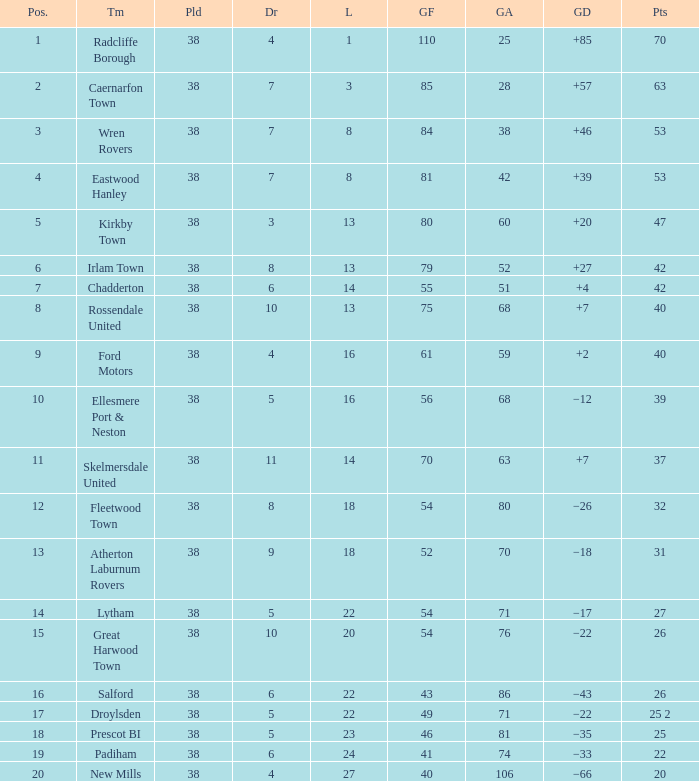How much Drawn has Goals Against larger than 74, and a Lost smaller than 20, and a Played larger than 38? 0.0. 